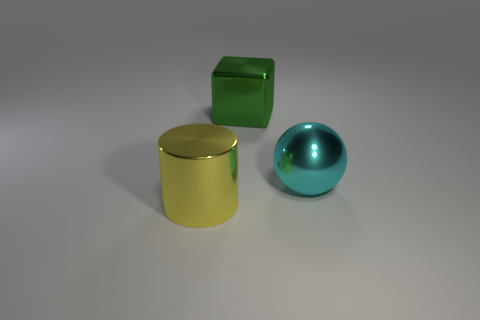Add 1 small shiny cylinders. How many objects exist? 4 Subtract all balls. How many objects are left? 2 Add 1 metallic blocks. How many metallic blocks exist? 2 Subtract 0 green cylinders. How many objects are left? 3 Subtract all red cylinders. Subtract all brown balls. How many cylinders are left? 1 Subtract all yellow cylinders. Subtract all metallic blocks. How many objects are left? 1 Add 1 cyan shiny spheres. How many cyan shiny spheres are left? 2 